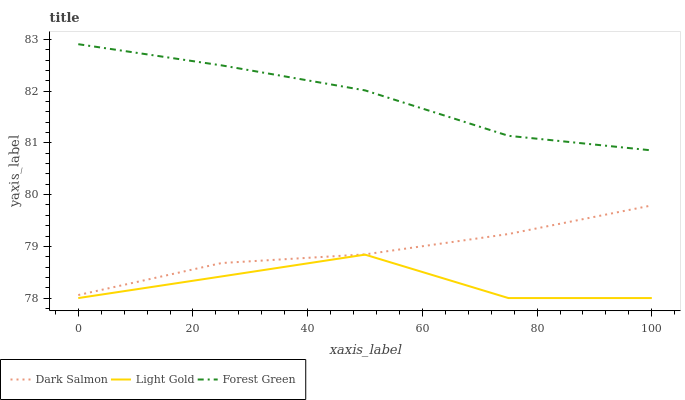Does Light Gold have the minimum area under the curve?
Answer yes or no. Yes. Does Forest Green have the maximum area under the curve?
Answer yes or no. Yes. Does Dark Salmon have the minimum area under the curve?
Answer yes or no. No. Does Dark Salmon have the maximum area under the curve?
Answer yes or no. No. Is Dark Salmon the smoothest?
Answer yes or no. Yes. Is Light Gold the roughest?
Answer yes or no. Yes. Is Light Gold the smoothest?
Answer yes or no. No. Is Dark Salmon the roughest?
Answer yes or no. No. Does Light Gold have the lowest value?
Answer yes or no. Yes. Does Dark Salmon have the lowest value?
Answer yes or no. No. Does Forest Green have the highest value?
Answer yes or no. Yes. Does Dark Salmon have the highest value?
Answer yes or no. No. Is Light Gold less than Dark Salmon?
Answer yes or no. Yes. Is Dark Salmon greater than Light Gold?
Answer yes or no. Yes. Does Light Gold intersect Dark Salmon?
Answer yes or no. No. 